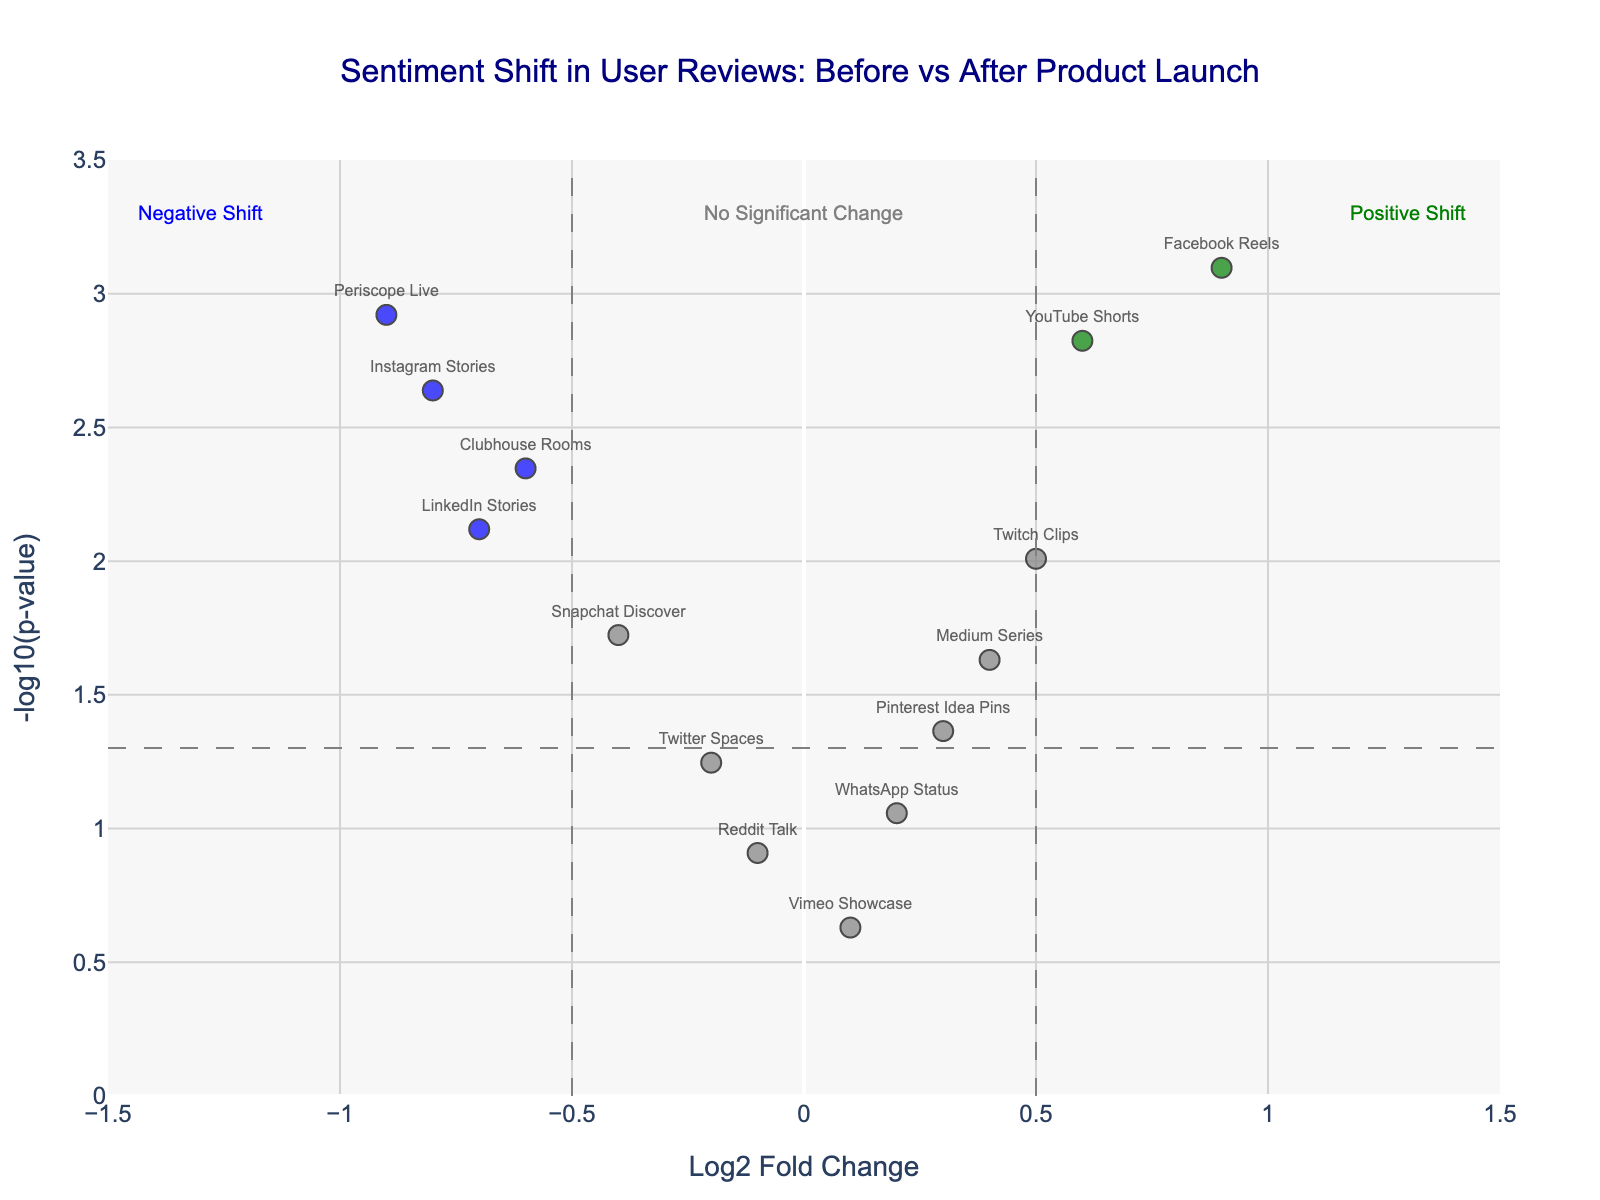What is the title of the figure? The title can be directly seen at the top of the figure. It reads: "Sentiment Shift in User Reviews: Before vs After Product Launch".
Answer: Sentiment Shift in User Reviews: Before vs After Product Launch What does a green data point represent? In the plot, green data points are categorized by specific visual information. They represent a significant positive shift in sentiment (Log2FoldChange > 0.5 and P-value < 0.05).
Answer: Significant positive shift How many data points show a significant negative shift? Negative shifts are represented by blue data points. Only LinkedIn Stories, Snapchat Discover, Clubhouse Rooms, and Periscope Live meet the criteria (Log2FoldChange < -0.5 and P-value < 0.05).
Answer: Four Which feature shows the maximum positive sentiment shift? The feature with the highest Log2FoldChange among the green data points indicates the maximum positive sentiment shift. TikTok For You Page shows the highest Log2FoldChange of 1.2.
Answer: TikTok For You Page Which feature is closest to the threshold for significance in the negative shift? The feature closest to significance in the negative shift has a Log2FoldChange below -0.5 and is closest to P-value threshold (0.05). Clubhouse Rooms with a P-value of 0.0045 and Log2FoldChange of -0.6 is closest among blue points near the threshold.
Answer: Clubhouse Rooms Which feature has the smallest (least significant) P-value? The smallest P-value is identified by the highest -log10(p-value). TikTok For You Page has the highest -log10(p-value) value, indicating the smallest P-value.
Answer: TikTok For You Page How many features do not show a significant shift? Features without significant shifts are represented by grey data points. These include Twitter Spaces, Reddit Talk, WhatsApp Status, Vimeo Showcase, and Pinterest Idea Pins.
Answer: Five Which feature has the highest -log10(p-value) value but does not have a significant change in sentiment? By looking for the grey point with the highest -log10(p-value). Pinterest Idea Pins, with a -log10(p-value) about ~1.36 but is not significant.
Answer: Pinterest Idea Pins Is Facebook Reels associated with a positive or negative sentiment shift, and how significant is it? Facebook Reels is represented by a green data point with a Log2FoldChange of 0.9 and a P-value of 0.0008. It signifies a positive shift and is highly significant based on both the thresholds.
Answer: Positive, highly significant 